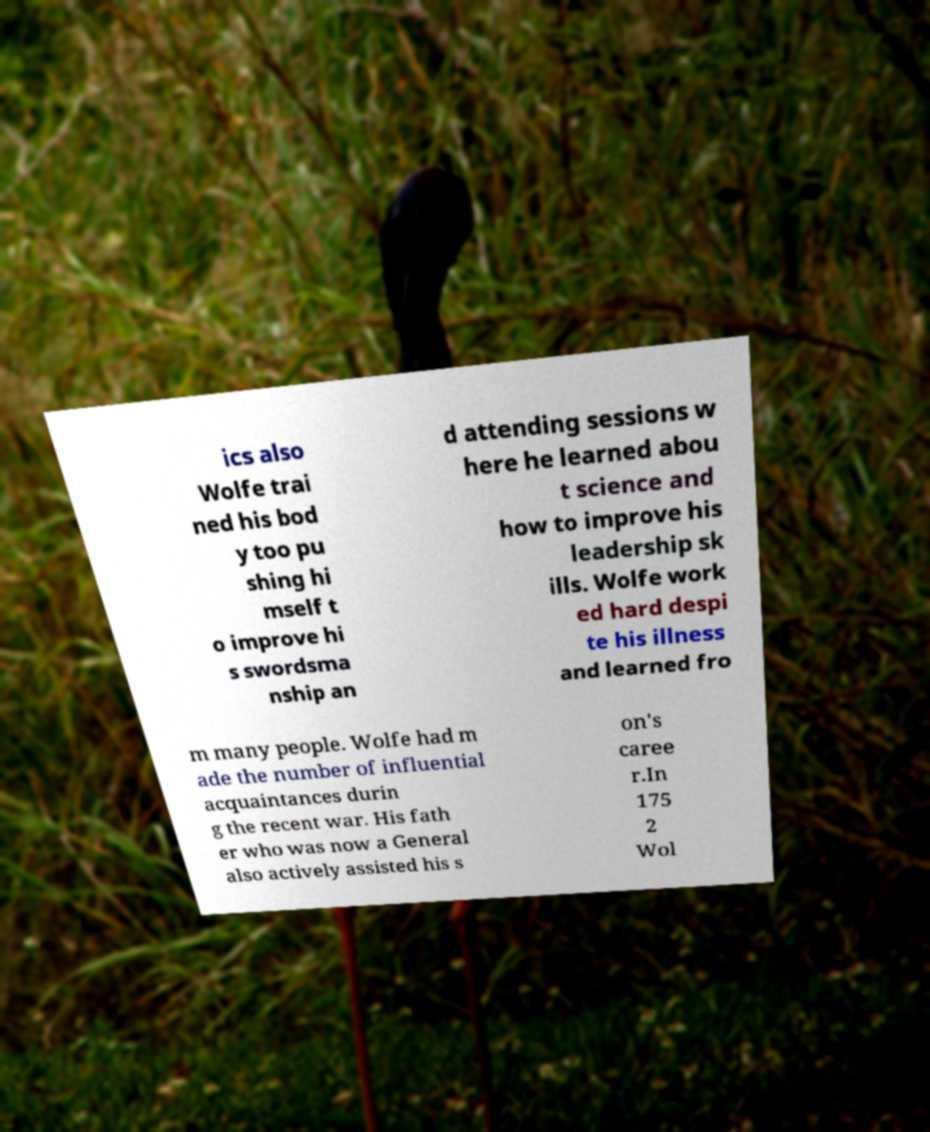There's text embedded in this image that I need extracted. Can you transcribe it verbatim? ics also Wolfe trai ned his bod y too pu shing hi mself t o improve hi s swordsma nship an d attending sessions w here he learned abou t science and how to improve his leadership sk ills. Wolfe work ed hard despi te his illness and learned fro m many people. Wolfe had m ade the number of influential acquaintances durin g the recent war. His fath er who was now a General also actively assisted his s on's caree r.In 175 2 Wol 